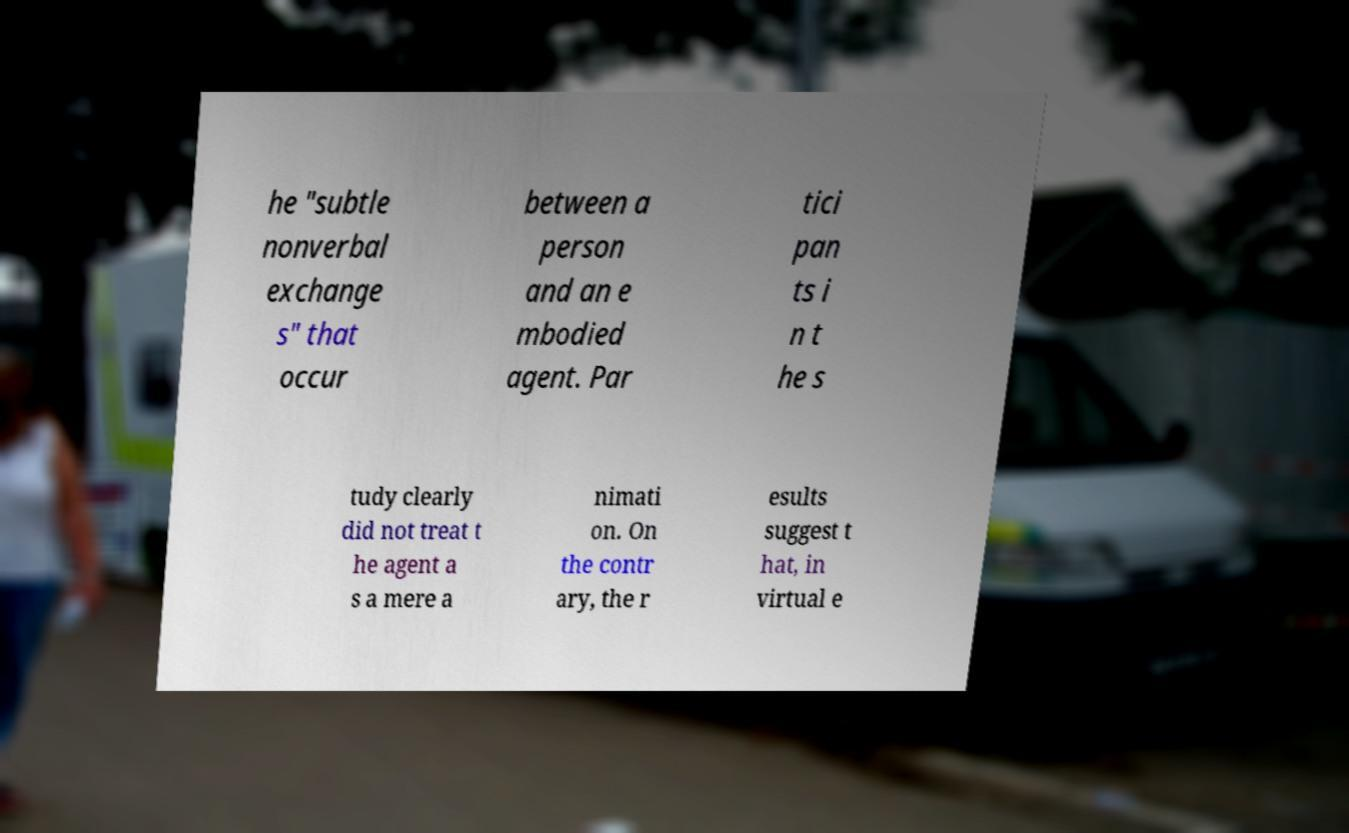There's text embedded in this image that I need extracted. Can you transcribe it verbatim? he "subtle nonverbal exchange s" that occur between a person and an e mbodied agent. Par tici pan ts i n t he s tudy clearly did not treat t he agent a s a mere a nimati on. On the contr ary, the r esults suggest t hat, in virtual e 